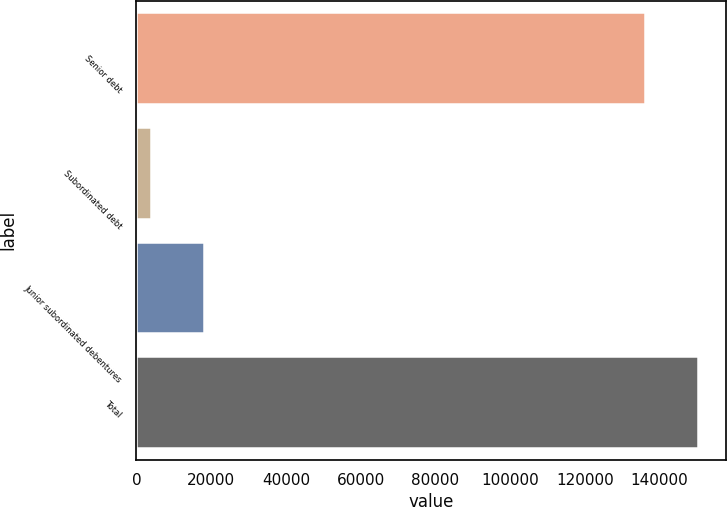<chart> <loc_0><loc_0><loc_500><loc_500><bar_chart><fcel>Senior debt<fcel>Subordinated debt<fcel>Junior subordinated debentures<fcel>Total<nl><fcel>136213<fcel>3881<fcel>17990.7<fcel>150323<nl></chart> 